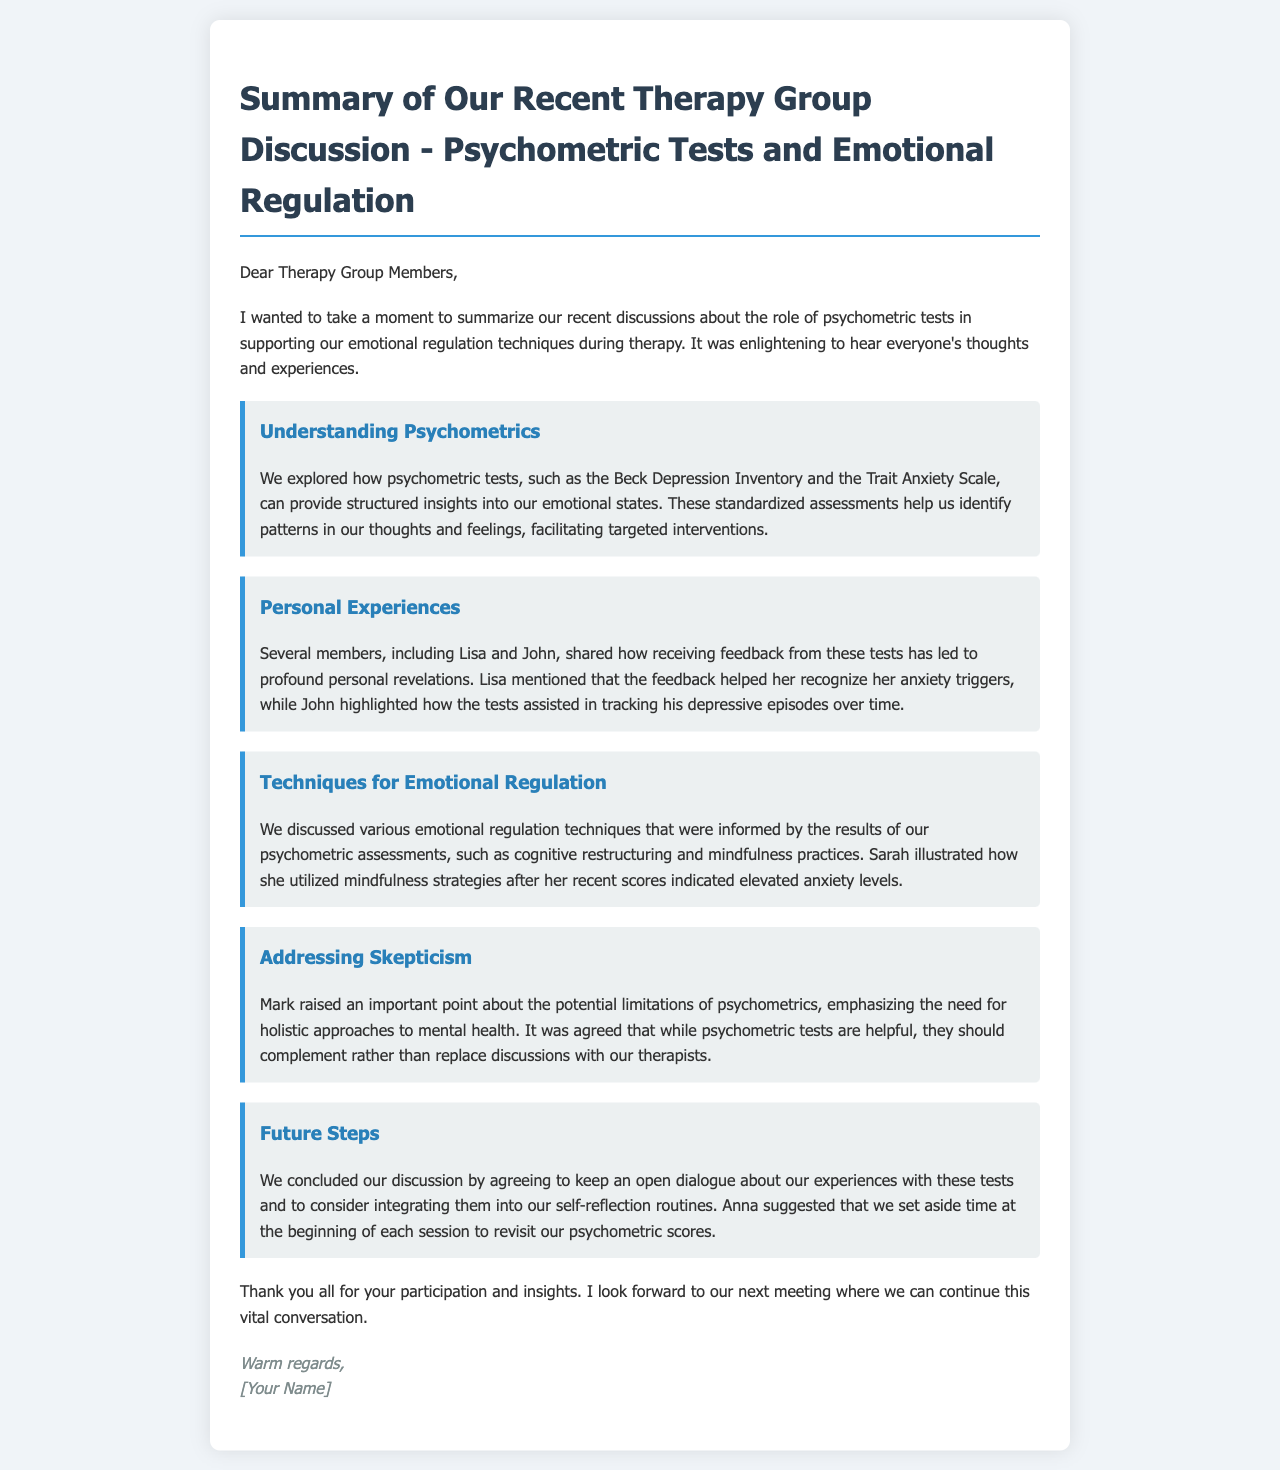What psychometric tests were mentioned? The document lists two specific tests: the Beck Depression Inventory and the Trait Anxiety Scale.
Answer: Beck Depression Inventory, Trait Anxiety Scale Who shared insights about anxiety triggers? Lisa is the member who mentioned recognizing her anxiety triggers due to feedback from psychometric tests.
Answer: Lisa Which emotional regulation technique was illustrated by Sarah? Sarah illustrated the use of mindfulness strategies as her emotional regulation technique related to her psychometric scores.
Answer: Mindfulness What concern did Mark raise during the discussion? Mark emphasized the need for holistic approaches to mental health, indicating some skepticism about relying solely on psychometric tests.
Answer: Limitations of psychometrics What did Anna suggest for future sessions? Anna suggested setting aside time at the beginning of each session to revisit psychometric scores, promoting ongoing self-reflection.
Answer: Revisit psychometric scores 